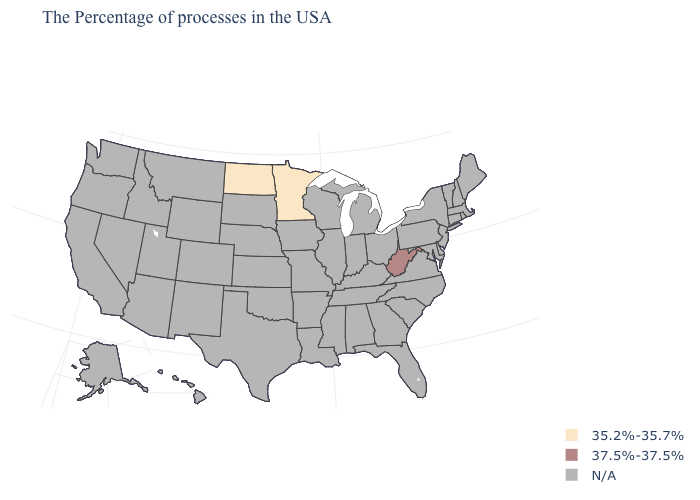Does the map have missing data?
Concise answer only. Yes. Which states have the highest value in the USA?
Be succinct. West Virginia. How many symbols are there in the legend?
Concise answer only. 3. Name the states that have a value in the range 35.2%-35.7%?
Write a very short answer. Minnesota, North Dakota. Name the states that have a value in the range 37.5%-37.5%?
Answer briefly. West Virginia. Is the legend a continuous bar?
Give a very brief answer. No. What is the highest value in the USA?
Quick response, please. 37.5%-37.5%. What is the value of West Virginia?
Concise answer only. 37.5%-37.5%. What is the highest value in states that border Wisconsin?
Short answer required. 35.2%-35.7%. Name the states that have a value in the range 35.2%-35.7%?
Quick response, please. Minnesota, North Dakota. 